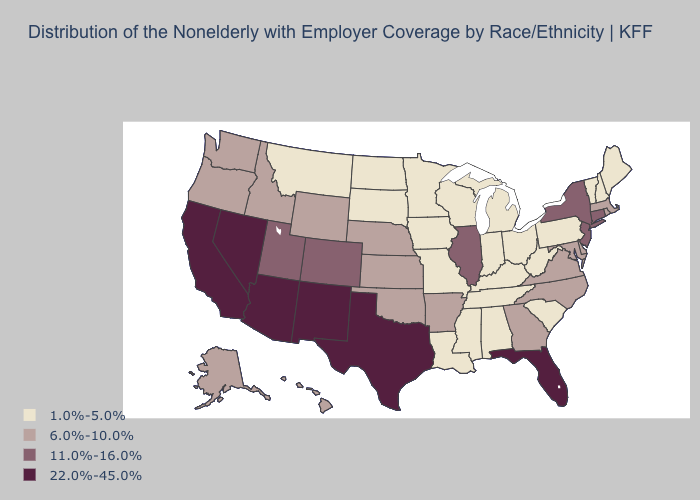What is the value of Kentucky?
Answer briefly. 1.0%-5.0%. Which states have the lowest value in the USA?
Write a very short answer. Alabama, Indiana, Iowa, Kentucky, Louisiana, Maine, Michigan, Minnesota, Mississippi, Missouri, Montana, New Hampshire, North Dakota, Ohio, Pennsylvania, South Carolina, South Dakota, Tennessee, Vermont, West Virginia, Wisconsin. What is the value of Oklahoma?
Be succinct. 6.0%-10.0%. Name the states that have a value in the range 1.0%-5.0%?
Concise answer only. Alabama, Indiana, Iowa, Kentucky, Louisiana, Maine, Michigan, Minnesota, Mississippi, Missouri, Montana, New Hampshire, North Dakota, Ohio, Pennsylvania, South Carolina, South Dakota, Tennessee, Vermont, West Virginia, Wisconsin. Among the states that border Wisconsin , which have the highest value?
Keep it brief. Illinois. How many symbols are there in the legend?
Write a very short answer. 4. Does the first symbol in the legend represent the smallest category?
Keep it brief. Yes. Name the states that have a value in the range 1.0%-5.0%?
Keep it brief. Alabama, Indiana, Iowa, Kentucky, Louisiana, Maine, Michigan, Minnesota, Mississippi, Missouri, Montana, New Hampshire, North Dakota, Ohio, Pennsylvania, South Carolina, South Dakota, Tennessee, Vermont, West Virginia, Wisconsin. What is the value of Minnesota?
Short answer required. 1.0%-5.0%. What is the value of Massachusetts?
Write a very short answer. 6.0%-10.0%. Does South Carolina have the lowest value in the USA?
Answer briefly. Yes. Does the map have missing data?
Quick response, please. No. Which states have the lowest value in the USA?
Answer briefly. Alabama, Indiana, Iowa, Kentucky, Louisiana, Maine, Michigan, Minnesota, Mississippi, Missouri, Montana, New Hampshire, North Dakota, Ohio, Pennsylvania, South Carolina, South Dakota, Tennessee, Vermont, West Virginia, Wisconsin. Name the states that have a value in the range 11.0%-16.0%?
Give a very brief answer. Colorado, Connecticut, Illinois, New Jersey, New York, Utah. Which states have the highest value in the USA?
Short answer required. Arizona, California, Florida, Nevada, New Mexico, Texas. 